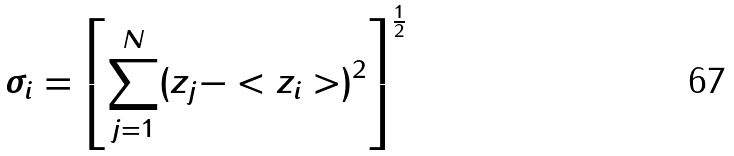<formula> <loc_0><loc_0><loc_500><loc_500>\sigma _ { i } = \left [ \sum _ { j = 1 } ^ { N } ( z _ { j } - < z _ { i } > ) ^ { 2 } \right ] ^ { \frac { 1 } { 2 } }</formula> 